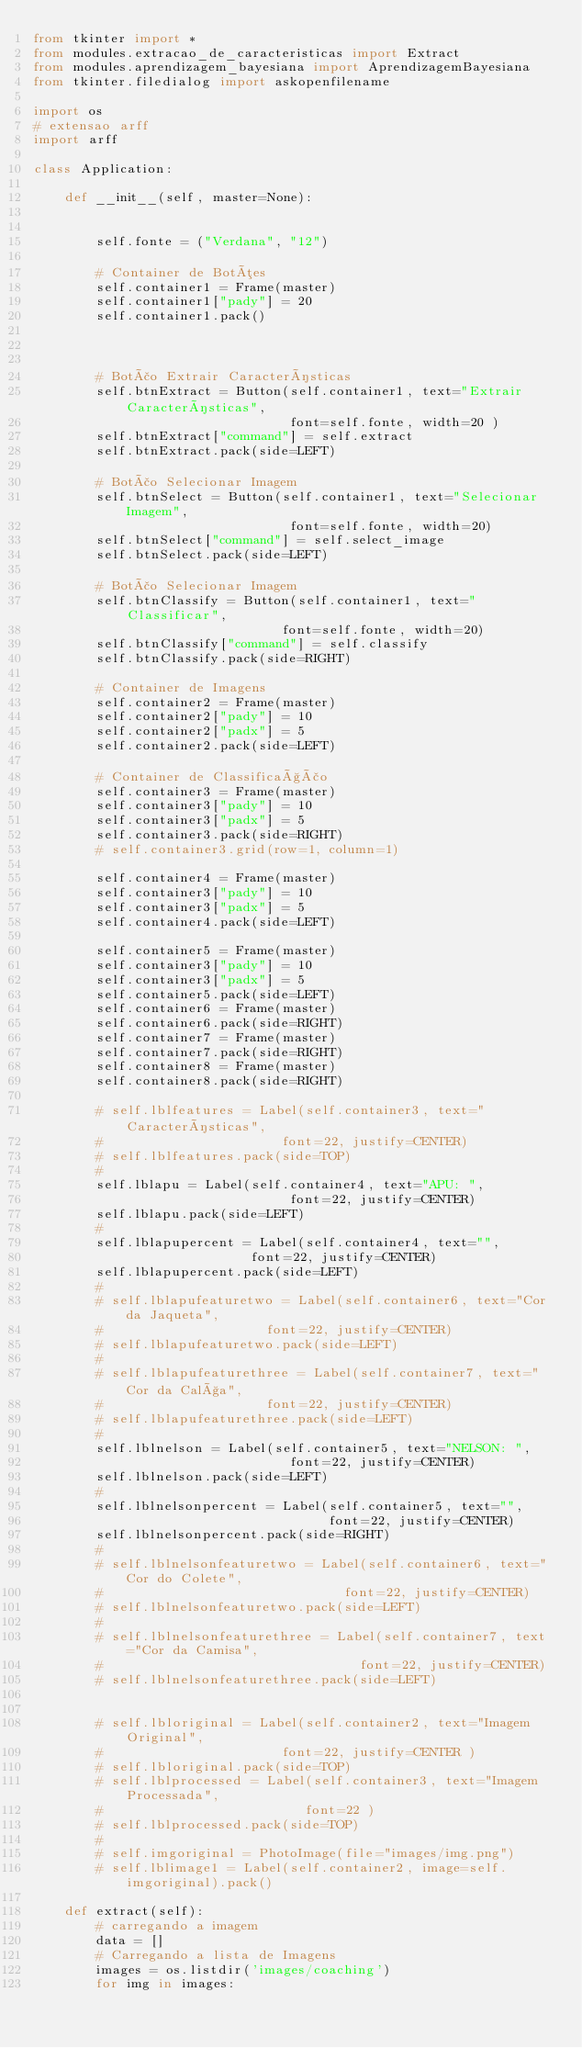Convert code to text. <code><loc_0><loc_0><loc_500><loc_500><_Python_>from tkinter import *
from modules.extracao_de_caracteristicas import Extract
from modules.aprendizagem_bayesiana import AprendizagemBayesiana
from tkinter.filedialog import askopenfilename

import os
# extensao arff
import arff

class Application:

    def __init__(self, master=None):


        self.fonte = ("Verdana", "12")

        # Container de Botões
        self.container1 = Frame(master)
        self.container1["pady"] = 20
        self.container1.pack()



        # Botão Extrair Características
        self.btnExtract = Button(self.container1, text="Extrair Características",
                                 font=self.fonte, width=20 )
        self.btnExtract["command"] = self.extract
        self.btnExtract.pack(side=LEFT)

        # Botão Selecionar Imagem
        self.btnSelect = Button(self.container1, text="Selecionar Imagem",
                                 font=self.fonte, width=20)
        self.btnSelect["command"] = self.select_image
        self.btnSelect.pack(side=LEFT)

        # Botão Selecionar Imagem
        self.btnClassify = Button(self.container1, text="Classificar",
                                font=self.fonte, width=20)
        self.btnClassify["command"] = self.classify
        self.btnClassify.pack(side=RIGHT)

        # Container de Imagens
        self.container2 = Frame(master)
        self.container2["pady"] = 10
        self.container2["padx"] = 5
        self.container2.pack(side=LEFT)

        # Container de Classificação
        self.container3 = Frame(master)
        self.container3["pady"] = 10
        self.container3["padx"] = 5
        self.container3.pack(side=RIGHT)
        # self.container3.grid(row=1, column=1)

        self.container4 = Frame(master)
        self.container3["pady"] = 10
        self.container3["padx"] = 5
        self.container4.pack(side=LEFT)

        self.container5 = Frame(master)
        self.container3["pady"] = 10
        self.container3["padx"] = 5
        self.container5.pack(side=LEFT)
        self.container6 = Frame(master)
        self.container6.pack(side=RIGHT)
        self.container7 = Frame(master)
        self.container7.pack(side=RIGHT)
        self.container8 = Frame(master)
        self.container8.pack(side=RIGHT)

        # self.lblfeatures = Label(self.container3, text="Características",
        #                       font=22, justify=CENTER)
        # self.lblfeatures.pack(side=TOP)
        #
        self.lblapu = Label(self.container4, text="APU: ",
                                 font=22, justify=CENTER)
        self.lblapu.pack(side=LEFT)
        #
        self.lblapupercent = Label(self.container4, text="",
                            font=22, justify=CENTER)
        self.lblapupercent.pack(side=LEFT)
        #
        # self.lblapufeaturetwo = Label(self.container6, text="Cor da Jaqueta",
        #                     font=22, justify=CENTER)
        # self.lblapufeaturetwo.pack(side=LEFT)
        #
        # self.lblapufeaturethree = Label(self.container7, text="Cor da Calça",
        #                     font=22, justify=CENTER)
        # self.lblapufeaturethree.pack(side=LEFT)
        #
        self.lblnelson = Label(self.container5, text="NELSON: ",
                                 font=22, justify=CENTER)
        self.lblnelson.pack(side=LEFT)
        #
        self.lblnelsonpercent = Label(self.container5, text="",
                                      font=22, justify=CENTER)
        self.lblnelsonpercent.pack(side=RIGHT)
        #
        # self.lblnelsonfeaturetwo = Label(self.container6, text="Cor do Colete",
        #                               font=22, justify=CENTER)
        # self.lblnelsonfeaturetwo.pack(side=LEFT)
        #
        # self.lblnelsonfeaturethree = Label(self.container7, text="Cor da Camisa",
        #                                 font=22, justify=CENTER)
        # self.lblnelsonfeaturethree.pack(side=LEFT)


        # self.lbloriginal = Label(self.container2, text="Imagem Original",
        #                       font=22, justify=CENTER )
        # self.lbloriginal.pack(side=TOP)
        # self.lblprocessed = Label(self.container3, text="Imagem Processada",
        #                          font=22 )
        # self.lblprocessed.pack(side=TOP)
        #
        # self.imgoriginal = PhotoImage(file="images/img.png")
        # self.lblimage1 = Label(self.container2, image=self.imgoriginal).pack()

    def extract(self):
        # carregando a imagem
        data = []
        # Carregando a lista de Imagens
        images = os.listdir('images/coaching')
        for img in images:</code> 